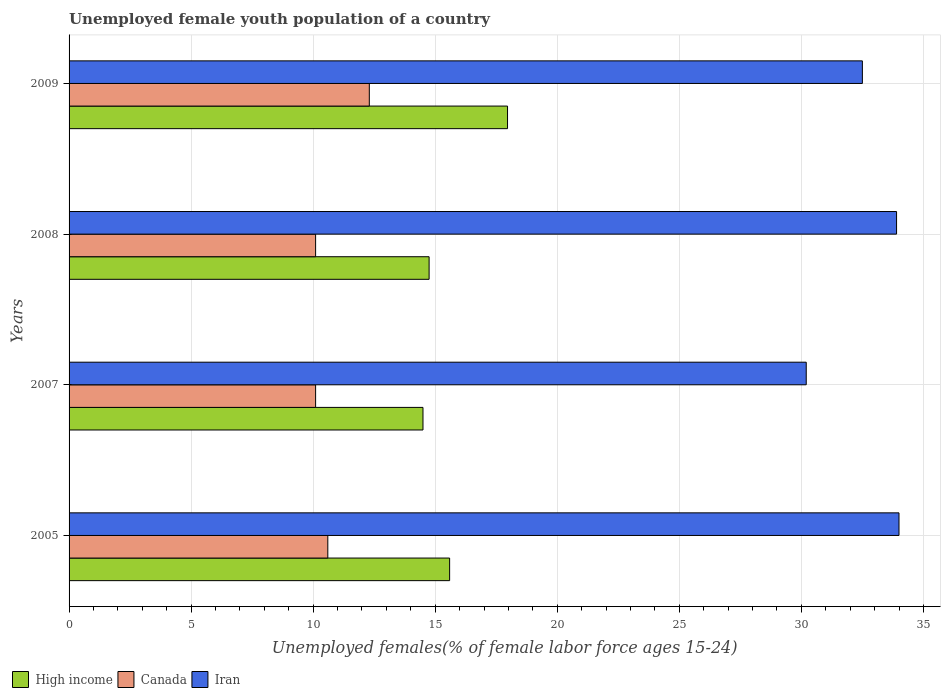How many groups of bars are there?
Your answer should be very brief. 4. Are the number of bars on each tick of the Y-axis equal?
Your response must be concise. Yes. How many bars are there on the 1st tick from the top?
Give a very brief answer. 3. How many bars are there on the 3rd tick from the bottom?
Offer a very short reply. 3. What is the percentage of unemployed female youth population in Canada in 2007?
Your answer should be compact. 10.1. Across all years, what is the minimum percentage of unemployed female youth population in Iran?
Make the answer very short. 30.2. In which year was the percentage of unemployed female youth population in Canada maximum?
Your response must be concise. 2009. What is the total percentage of unemployed female youth population in Iran in the graph?
Your response must be concise. 130.6. What is the difference between the percentage of unemployed female youth population in Iran in 2005 and that in 2007?
Ensure brevity in your answer.  3.8. What is the difference between the percentage of unemployed female youth population in Canada in 2005 and the percentage of unemployed female youth population in Iran in 2008?
Ensure brevity in your answer.  -23.3. What is the average percentage of unemployed female youth population in Canada per year?
Offer a terse response. 10.78. In the year 2008, what is the difference between the percentage of unemployed female youth population in Canada and percentage of unemployed female youth population in Iran?
Provide a succinct answer. -23.8. In how many years, is the percentage of unemployed female youth population in Iran greater than 15 %?
Keep it short and to the point. 4. What is the ratio of the percentage of unemployed female youth population in Iran in 2008 to that in 2009?
Provide a short and direct response. 1.04. Is the difference between the percentage of unemployed female youth population in Canada in 2005 and 2009 greater than the difference between the percentage of unemployed female youth population in Iran in 2005 and 2009?
Offer a very short reply. No. What is the difference between the highest and the second highest percentage of unemployed female youth population in High income?
Offer a terse response. 2.37. What is the difference between the highest and the lowest percentage of unemployed female youth population in Canada?
Make the answer very short. 2.2. Is the sum of the percentage of unemployed female youth population in High income in 2005 and 2008 greater than the maximum percentage of unemployed female youth population in Iran across all years?
Your response must be concise. No. What does the 3rd bar from the top in 2008 represents?
Provide a succinct answer. High income. What does the 2nd bar from the bottom in 2005 represents?
Give a very brief answer. Canada. What is the difference between two consecutive major ticks on the X-axis?
Offer a terse response. 5. Does the graph contain grids?
Make the answer very short. Yes. What is the title of the graph?
Provide a short and direct response. Unemployed female youth population of a country. What is the label or title of the X-axis?
Give a very brief answer. Unemployed females(% of female labor force ages 15-24). What is the label or title of the Y-axis?
Ensure brevity in your answer.  Years. What is the Unemployed females(% of female labor force ages 15-24) of High income in 2005?
Keep it short and to the point. 15.59. What is the Unemployed females(% of female labor force ages 15-24) of Canada in 2005?
Give a very brief answer. 10.6. What is the Unemployed females(% of female labor force ages 15-24) in Iran in 2005?
Keep it short and to the point. 34. What is the Unemployed females(% of female labor force ages 15-24) in High income in 2007?
Keep it short and to the point. 14.5. What is the Unemployed females(% of female labor force ages 15-24) of Canada in 2007?
Ensure brevity in your answer.  10.1. What is the Unemployed females(% of female labor force ages 15-24) of Iran in 2007?
Provide a succinct answer. 30.2. What is the Unemployed females(% of female labor force ages 15-24) of High income in 2008?
Make the answer very short. 14.75. What is the Unemployed females(% of female labor force ages 15-24) in Canada in 2008?
Make the answer very short. 10.1. What is the Unemployed females(% of female labor force ages 15-24) of Iran in 2008?
Make the answer very short. 33.9. What is the Unemployed females(% of female labor force ages 15-24) in High income in 2009?
Provide a short and direct response. 17.96. What is the Unemployed females(% of female labor force ages 15-24) of Canada in 2009?
Your answer should be very brief. 12.3. What is the Unemployed females(% of female labor force ages 15-24) in Iran in 2009?
Give a very brief answer. 32.5. Across all years, what is the maximum Unemployed females(% of female labor force ages 15-24) in High income?
Give a very brief answer. 17.96. Across all years, what is the maximum Unemployed females(% of female labor force ages 15-24) of Canada?
Provide a succinct answer. 12.3. Across all years, what is the minimum Unemployed females(% of female labor force ages 15-24) of High income?
Your response must be concise. 14.5. Across all years, what is the minimum Unemployed females(% of female labor force ages 15-24) of Canada?
Offer a terse response. 10.1. Across all years, what is the minimum Unemployed females(% of female labor force ages 15-24) of Iran?
Give a very brief answer. 30.2. What is the total Unemployed females(% of female labor force ages 15-24) of High income in the graph?
Offer a very short reply. 62.8. What is the total Unemployed females(% of female labor force ages 15-24) of Canada in the graph?
Make the answer very short. 43.1. What is the total Unemployed females(% of female labor force ages 15-24) in Iran in the graph?
Your answer should be very brief. 130.6. What is the difference between the Unemployed females(% of female labor force ages 15-24) in High income in 2005 and that in 2007?
Your response must be concise. 1.09. What is the difference between the Unemployed females(% of female labor force ages 15-24) in Iran in 2005 and that in 2007?
Offer a terse response. 3.8. What is the difference between the Unemployed females(% of female labor force ages 15-24) in High income in 2005 and that in 2008?
Your response must be concise. 0.84. What is the difference between the Unemployed females(% of female labor force ages 15-24) of High income in 2005 and that in 2009?
Your answer should be compact. -2.37. What is the difference between the Unemployed females(% of female labor force ages 15-24) of Iran in 2005 and that in 2009?
Offer a very short reply. 1.5. What is the difference between the Unemployed females(% of female labor force ages 15-24) in High income in 2007 and that in 2008?
Ensure brevity in your answer.  -0.25. What is the difference between the Unemployed females(% of female labor force ages 15-24) in High income in 2007 and that in 2009?
Offer a terse response. -3.46. What is the difference between the Unemployed females(% of female labor force ages 15-24) in High income in 2008 and that in 2009?
Provide a short and direct response. -3.21. What is the difference between the Unemployed females(% of female labor force ages 15-24) in Canada in 2008 and that in 2009?
Offer a terse response. -2.2. What is the difference between the Unemployed females(% of female labor force ages 15-24) of High income in 2005 and the Unemployed females(% of female labor force ages 15-24) of Canada in 2007?
Your answer should be compact. 5.49. What is the difference between the Unemployed females(% of female labor force ages 15-24) in High income in 2005 and the Unemployed females(% of female labor force ages 15-24) in Iran in 2007?
Your response must be concise. -14.61. What is the difference between the Unemployed females(% of female labor force ages 15-24) in Canada in 2005 and the Unemployed females(% of female labor force ages 15-24) in Iran in 2007?
Provide a short and direct response. -19.6. What is the difference between the Unemployed females(% of female labor force ages 15-24) of High income in 2005 and the Unemployed females(% of female labor force ages 15-24) of Canada in 2008?
Make the answer very short. 5.49. What is the difference between the Unemployed females(% of female labor force ages 15-24) in High income in 2005 and the Unemployed females(% of female labor force ages 15-24) in Iran in 2008?
Offer a very short reply. -18.31. What is the difference between the Unemployed females(% of female labor force ages 15-24) of Canada in 2005 and the Unemployed females(% of female labor force ages 15-24) of Iran in 2008?
Give a very brief answer. -23.3. What is the difference between the Unemployed females(% of female labor force ages 15-24) of High income in 2005 and the Unemployed females(% of female labor force ages 15-24) of Canada in 2009?
Offer a very short reply. 3.29. What is the difference between the Unemployed females(% of female labor force ages 15-24) in High income in 2005 and the Unemployed females(% of female labor force ages 15-24) in Iran in 2009?
Make the answer very short. -16.91. What is the difference between the Unemployed females(% of female labor force ages 15-24) of Canada in 2005 and the Unemployed females(% of female labor force ages 15-24) of Iran in 2009?
Offer a very short reply. -21.9. What is the difference between the Unemployed females(% of female labor force ages 15-24) in High income in 2007 and the Unemployed females(% of female labor force ages 15-24) in Canada in 2008?
Ensure brevity in your answer.  4.4. What is the difference between the Unemployed females(% of female labor force ages 15-24) in High income in 2007 and the Unemployed females(% of female labor force ages 15-24) in Iran in 2008?
Offer a terse response. -19.4. What is the difference between the Unemployed females(% of female labor force ages 15-24) of Canada in 2007 and the Unemployed females(% of female labor force ages 15-24) of Iran in 2008?
Give a very brief answer. -23.8. What is the difference between the Unemployed females(% of female labor force ages 15-24) of High income in 2007 and the Unemployed females(% of female labor force ages 15-24) of Canada in 2009?
Provide a short and direct response. 2.2. What is the difference between the Unemployed females(% of female labor force ages 15-24) in High income in 2007 and the Unemployed females(% of female labor force ages 15-24) in Iran in 2009?
Your answer should be very brief. -18. What is the difference between the Unemployed females(% of female labor force ages 15-24) in Canada in 2007 and the Unemployed females(% of female labor force ages 15-24) in Iran in 2009?
Keep it short and to the point. -22.4. What is the difference between the Unemployed females(% of female labor force ages 15-24) of High income in 2008 and the Unemployed females(% of female labor force ages 15-24) of Canada in 2009?
Your answer should be compact. 2.45. What is the difference between the Unemployed females(% of female labor force ages 15-24) of High income in 2008 and the Unemployed females(% of female labor force ages 15-24) of Iran in 2009?
Your answer should be compact. -17.75. What is the difference between the Unemployed females(% of female labor force ages 15-24) of Canada in 2008 and the Unemployed females(% of female labor force ages 15-24) of Iran in 2009?
Offer a very short reply. -22.4. What is the average Unemployed females(% of female labor force ages 15-24) of High income per year?
Offer a very short reply. 15.7. What is the average Unemployed females(% of female labor force ages 15-24) of Canada per year?
Provide a succinct answer. 10.78. What is the average Unemployed females(% of female labor force ages 15-24) of Iran per year?
Provide a short and direct response. 32.65. In the year 2005, what is the difference between the Unemployed females(% of female labor force ages 15-24) in High income and Unemployed females(% of female labor force ages 15-24) in Canada?
Give a very brief answer. 4.99. In the year 2005, what is the difference between the Unemployed females(% of female labor force ages 15-24) of High income and Unemployed females(% of female labor force ages 15-24) of Iran?
Offer a very short reply. -18.41. In the year 2005, what is the difference between the Unemployed females(% of female labor force ages 15-24) of Canada and Unemployed females(% of female labor force ages 15-24) of Iran?
Offer a terse response. -23.4. In the year 2007, what is the difference between the Unemployed females(% of female labor force ages 15-24) of High income and Unemployed females(% of female labor force ages 15-24) of Canada?
Make the answer very short. 4.4. In the year 2007, what is the difference between the Unemployed females(% of female labor force ages 15-24) in High income and Unemployed females(% of female labor force ages 15-24) in Iran?
Your answer should be compact. -15.7. In the year 2007, what is the difference between the Unemployed females(% of female labor force ages 15-24) in Canada and Unemployed females(% of female labor force ages 15-24) in Iran?
Offer a terse response. -20.1. In the year 2008, what is the difference between the Unemployed females(% of female labor force ages 15-24) in High income and Unemployed females(% of female labor force ages 15-24) in Canada?
Provide a succinct answer. 4.65. In the year 2008, what is the difference between the Unemployed females(% of female labor force ages 15-24) in High income and Unemployed females(% of female labor force ages 15-24) in Iran?
Your response must be concise. -19.15. In the year 2008, what is the difference between the Unemployed females(% of female labor force ages 15-24) of Canada and Unemployed females(% of female labor force ages 15-24) of Iran?
Your answer should be compact. -23.8. In the year 2009, what is the difference between the Unemployed females(% of female labor force ages 15-24) in High income and Unemployed females(% of female labor force ages 15-24) in Canada?
Keep it short and to the point. 5.66. In the year 2009, what is the difference between the Unemployed females(% of female labor force ages 15-24) of High income and Unemployed females(% of female labor force ages 15-24) of Iran?
Keep it short and to the point. -14.54. In the year 2009, what is the difference between the Unemployed females(% of female labor force ages 15-24) of Canada and Unemployed females(% of female labor force ages 15-24) of Iran?
Your response must be concise. -20.2. What is the ratio of the Unemployed females(% of female labor force ages 15-24) in High income in 2005 to that in 2007?
Provide a short and direct response. 1.08. What is the ratio of the Unemployed females(% of female labor force ages 15-24) of Canada in 2005 to that in 2007?
Your answer should be compact. 1.05. What is the ratio of the Unemployed females(% of female labor force ages 15-24) in Iran in 2005 to that in 2007?
Your response must be concise. 1.13. What is the ratio of the Unemployed females(% of female labor force ages 15-24) of High income in 2005 to that in 2008?
Ensure brevity in your answer.  1.06. What is the ratio of the Unemployed females(% of female labor force ages 15-24) in Canada in 2005 to that in 2008?
Keep it short and to the point. 1.05. What is the ratio of the Unemployed females(% of female labor force ages 15-24) of Iran in 2005 to that in 2008?
Give a very brief answer. 1. What is the ratio of the Unemployed females(% of female labor force ages 15-24) in High income in 2005 to that in 2009?
Your answer should be compact. 0.87. What is the ratio of the Unemployed females(% of female labor force ages 15-24) of Canada in 2005 to that in 2009?
Provide a short and direct response. 0.86. What is the ratio of the Unemployed females(% of female labor force ages 15-24) of Iran in 2005 to that in 2009?
Offer a very short reply. 1.05. What is the ratio of the Unemployed females(% of female labor force ages 15-24) of Iran in 2007 to that in 2008?
Keep it short and to the point. 0.89. What is the ratio of the Unemployed females(% of female labor force ages 15-24) in High income in 2007 to that in 2009?
Provide a short and direct response. 0.81. What is the ratio of the Unemployed females(% of female labor force ages 15-24) of Canada in 2007 to that in 2009?
Offer a very short reply. 0.82. What is the ratio of the Unemployed females(% of female labor force ages 15-24) in Iran in 2007 to that in 2009?
Offer a very short reply. 0.93. What is the ratio of the Unemployed females(% of female labor force ages 15-24) in High income in 2008 to that in 2009?
Ensure brevity in your answer.  0.82. What is the ratio of the Unemployed females(% of female labor force ages 15-24) of Canada in 2008 to that in 2009?
Give a very brief answer. 0.82. What is the ratio of the Unemployed females(% of female labor force ages 15-24) in Iran in 2008 to that in 2009?
Keep it short and to the point. 1.04. What is the difference between the highest and the second highest Unemployed females(% of female labor force ages 15-24) in High income?
Make the answer very short. 2.37. What is the difference between the highest and the second highest Unemployed females(% of female labor force ages 15-24) in Iran?
Your answer should be very brief. 0.1. What is the difference between the highest and the lowest Unemployed females(% of female labor force ages 15-24) of High income?
Provide a short and direct response. 3.46. What is the difference between the highest and the lowest Unemployed females(% of female labor force ages 15-24) of Canada?
Ensure brevity in your answer.  2.2. 